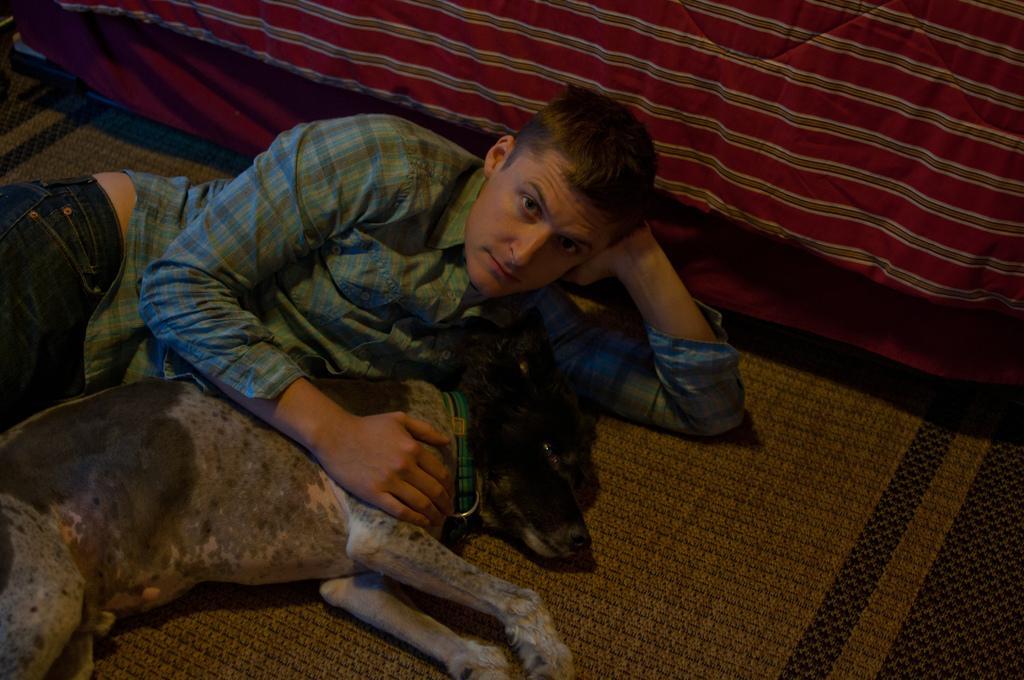Describe this image in one or two sentences. a person and a dog is laying on the floor. behind them there is a bed. 